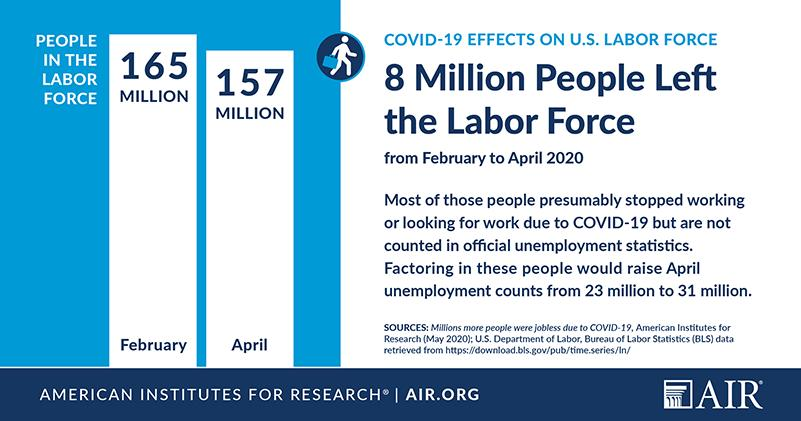List a handful of essential elements in this visual. In February 2020, there were approximately 165 million people participating in the labor force in the United States. In April 2020, there were approximately 157 million people participating in the U.S. labor force. 